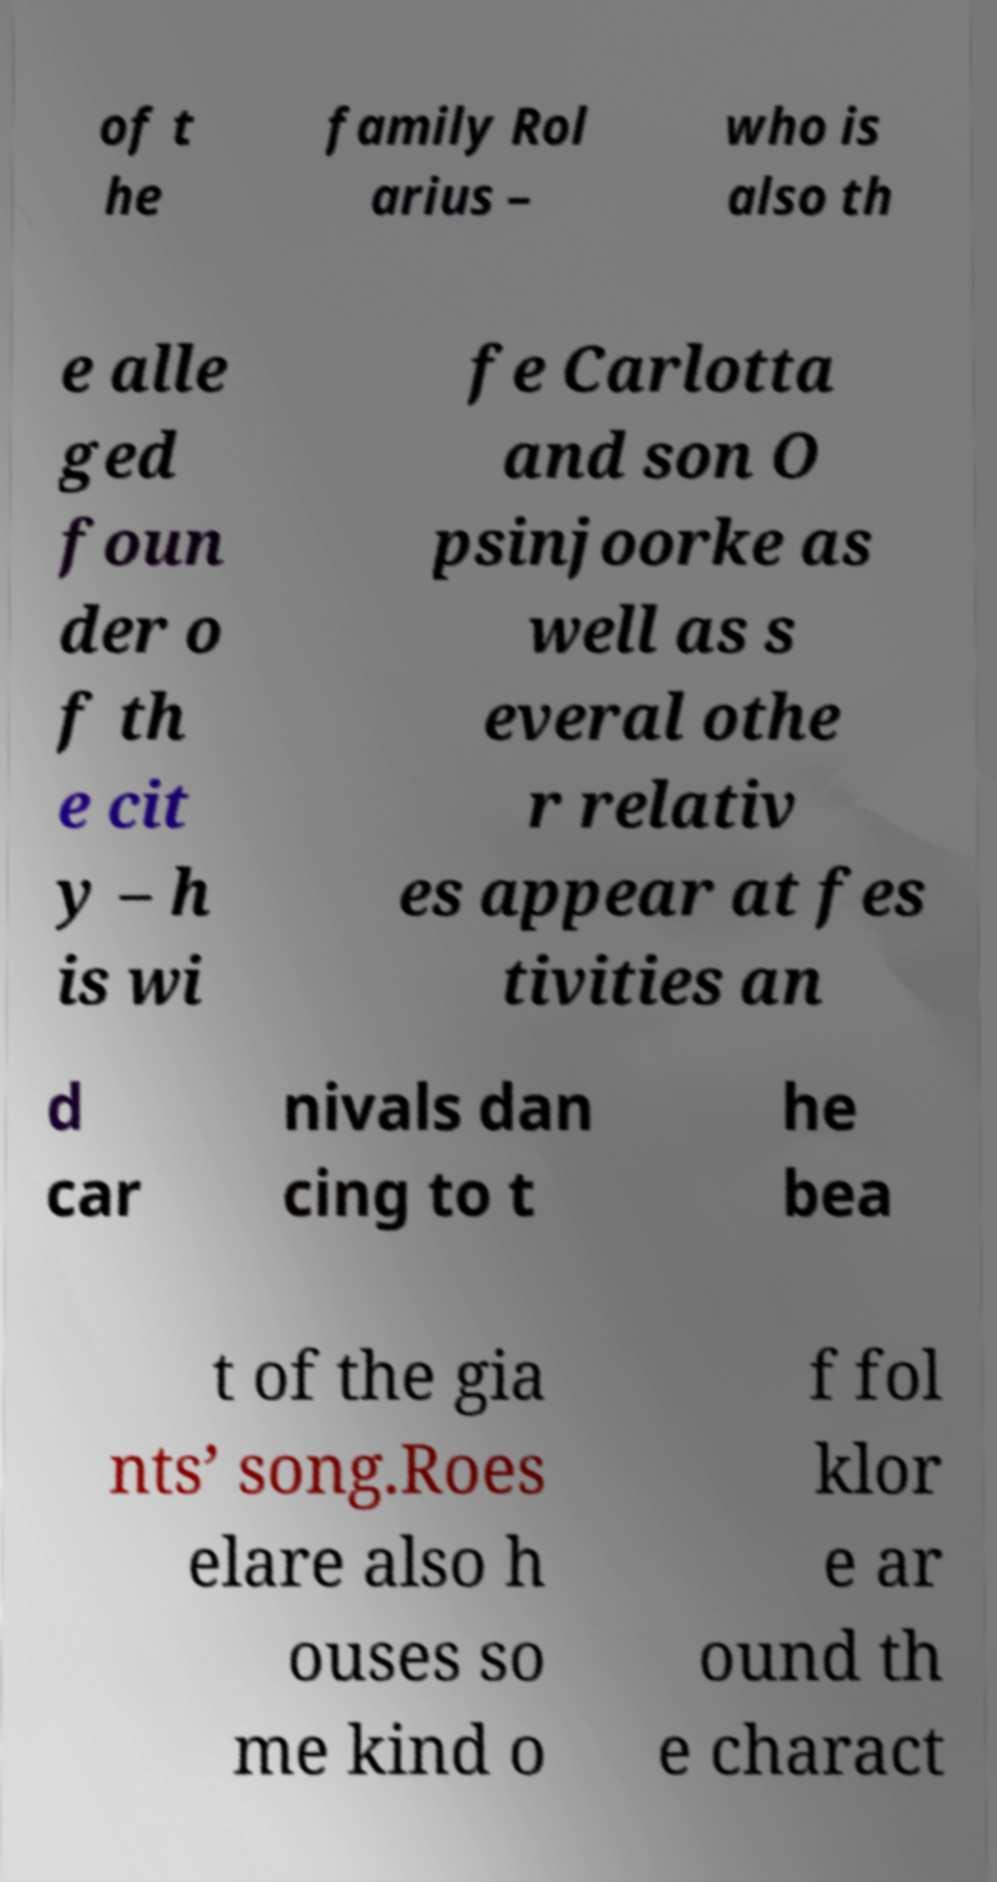I need the written content from this picture converted into text. Can you do that? of t he family Rol arius – who is also th e alle ged foun der o f th e cit y – h is wi fe Carlotta and son O psinjoorke as well as s everal othe r relativ es appear at fes tivities an d car nivals dan cing to t he bea t of the gia nts’ song.Roes elare also h ouses so me kind o f fol klor e ar ound th e charact 